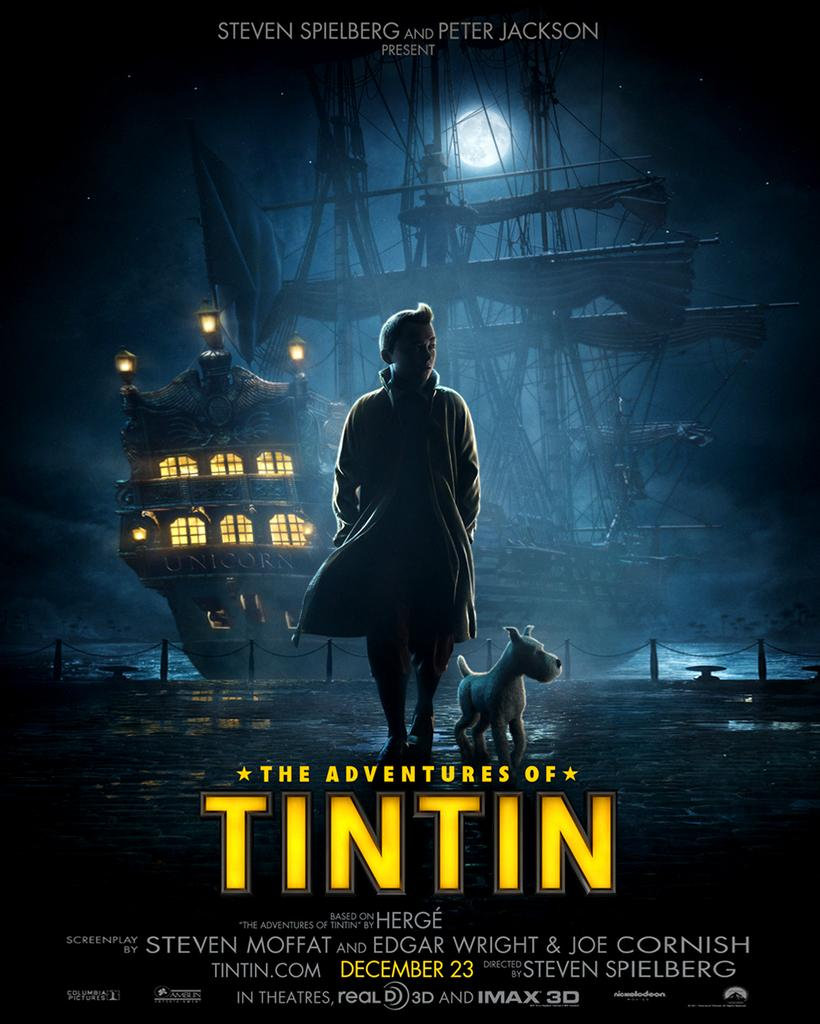Provide a one-sentence caption for the provided image. A movie poster beckons moviegoers to enjoy the adventures of young Belgian reporter Tintin. 